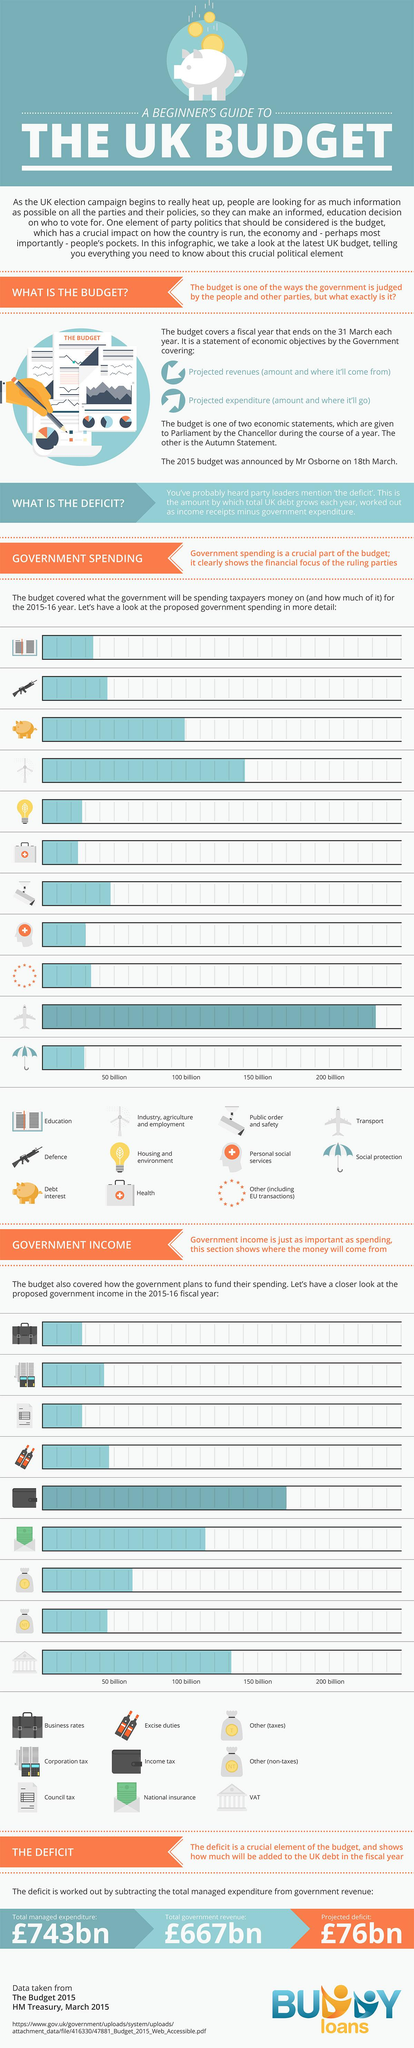Give some essential details in this illustration. The government's income in the area of Value Added Tax (VAT) is the second-highest. In two areas, the government's income is less than 50 billion. In how many areas does the government's income exceed 200 billion? The government spends more than 200 billion in the transportation sector. The symbol 'gun' represents the branch of defense. 